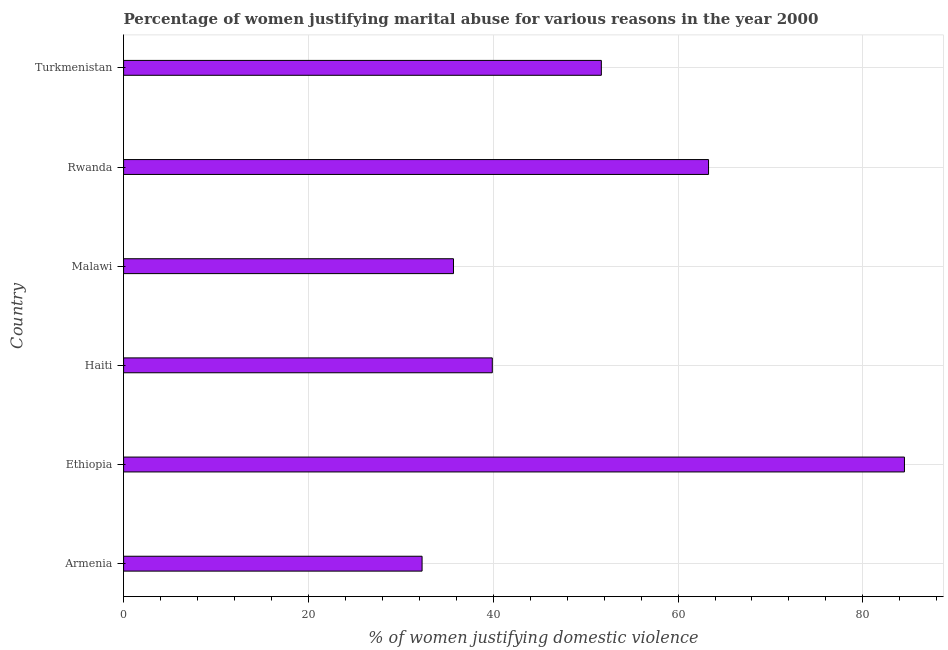Does the graph contain grids?
Offer a very short reply. Yes. What is the title of the graph?
Provide a succinct answer. Percentage of women justifying marital abuse for various reasons in the year 2000. What is the label or title of the X-axis?
Your response must be concise. % of women justifying domestic violence. What is the label or title of the Y-axis?
Your answer should be compact. Country. What is the percentage of women justifying marital abuse in Malawi?
Your answer should be very brief. 35.7. Across all countries, what is the maximum percentage of women justifying marital abuse?
Make the answer very short. 84.5. Across all countries, what is the minimum percentage of women justifying marital abuse?
Provide a short and direct response. 32.3. In which country was the percentage of women justifying marital abuse maximum?
Your answer should be very brief. Ethiopia. In which country was the percentage of women justifying marital abuse minimum?
Offer a terse response. Armenia. What is the sum of the percentage of women justifying marital abuse?
Ensure brevity in your answer.  307.4. What is the difference between the percentage of women justifying marital abuse in Haiti and Rwanda?
Your answer should be very brief. -23.4. What is the average percentage of women justifying marital abuse per country?
Your answer should be very brief. 51.23. What is the median percentage of women justifying marital abuse?
Your answer should be very brief. 45.8. In how many countries, is the percentage of women justifying marital abuse greater than 52 %?
Provide a short and direct response. 2. What is the ratio of the percentage of women justifying marital abuse in Rwanda to that in Turkmenistan?
Your response must be concise. 1.22. Is the difference between the percentage of women justifying marital abuse in Ethiopia and Rwanda greater than the difference between any two countries?
Provide a short and direct response. No. What is the difference between the highest and the second highest percentage of women justifying marital abuse?
Provide a succinct answer. 21.2. What is the difference between the highest and the lowest percentage of women justifying marital abuse?
Ensure brevity in your answer.  52.2. In how many countries, is the percentage of women justifying marital abuse greater than the average percentage of women justifying marital abuse taken over all countries?
Ensure brevity in your answer.  3. How many bars are there?
Make the answer very short. 6. Are all the bars in the graph horizontal?
Your answer should be compact. Yes. How many countries are there in the graph?
Provide a succinct answer. 6. What is the % of women justifying domestic violence in Armenia?
Keep it short and to the point. 32.3. What is the % of women justifying domestic violence in Ethiopia?
Provide a short and direct response. 84.5. What is the % of women justifying domestic violence of Haiti?
Ensure brevity in your answer.  39.9. What is the % of women justifying domestic violence of Malawi?
Offer a terse response. 35.7. What is the % of women justifying domestic violence in Rwanda?
Keep it short and to the point. 63.3. What is the % of women justifying domestic violence of Turkmenistan?
Offer a terse response. 51.7. What is the difference between the % of women justifying domestic violence in Armenia and Ethiopia?
Ensure brevity in your answer.  -52.2. What is the difference between the % of women justifying domestic violence in Armenia and Rwanda?
Your answer should be compact. -31. What is the difference between the % of women justifying domestic violence in Armenia and Turkmenistan?
Your response must be concise. -19.4. What is the difference between the % of women justifying domestic violence in Ethiopia and Haiti?
Make the answer very short. 44.6. What is the difference between the % of women justifying domestic violence in Ethiopia and Malawi?
Your response must be concise. 48.8. What is the difference between the % of women justifying domestic violence in Ethiopia and Rwanda?
Keep it short and to the point. 21.2. What is the difference between the % of women justifying domestic violence in Ethiopia and Turkmenistan?
Keep it short and to the point. 32.8. What is the difference between the % of women justifying domestic violence in Haiti and Rwanda?
Offer a terse response. -23.4. What is the difference between the % of women justifying domestic violence in Haiti and Turkmenistan?
Offer a terse response. -11.8. What is the difference between the % of women justifying domestic violence in Malawi and Rwanda?
Give a very brief answer. -27.6. What is the difference between the % of women justifying domestic violence in Rwanda and Turkmenistan?
Your answer should be compact. 11.6. What is the ratio of the % of women justifying domestic violence in Armenia to that in Ethiopia?
Your response must be concise. 0.38. What is the ratio of the % of women justifying domestic violence in Armenia to that in Haiti?
Ensure brevity in your answer.  0.81. What is the ratio of the % of women justifying domestic violence in Armenia to that in Malawi?
Give a very brief answer. 0.91. What is the ratio of the % of women justifying domestic violence in Armenia to that in Rwanda?
Your response must be concise. 0.51. What is the ratio of the % of women justifying domestic violence in Armenia to that in Turkmenistan?
Give a very brief answer. 0.62. What is the ratio of the % of women justifying domestic violence in Ethiopia to that in Haiti?
Provide a succinct answer. 2.12. What is the ratio of the % of women justifying domestic violence in Ethiopia to that in Malawi?
Offer a terse response. 2.37. What is the ratio of the % of women justifying domestic violence in Ethiopia to that in Rwanda?
Offer a terse response. 1.33. What is the ratio of the % of women justifying domestic violence in Ethiopia to that in Turkmenistan?
Ensure brevity in your answer.  1.63. What is the ratio of the % of women justifying domestic violence in Haiti to that in Malawi?
Keep it short and to the point. 1.12. What is the ratio of the % of women justifying domestic violence in Haiti to that in Rwanda?
Your response must be concise. 0.63. What is the ratio of the % of women justifying domestic violence in Haiti to that in Turkmenistan?
Provide a succinct answer. 0.77. What is the ratio of the % of women justifying domestic violence in Malawi to that in Rwanda?
Your answer should be very brief. 0.56. What is the ratio of the % of women justifying domestic violence in Malawi to that in Turkmenistan?
Your answer should be compact. 0.69. What is the ratio of the % of women justifying domestic violence in Rwanda to that in Turkmenistan?
Your response must be concise. 1.22. 